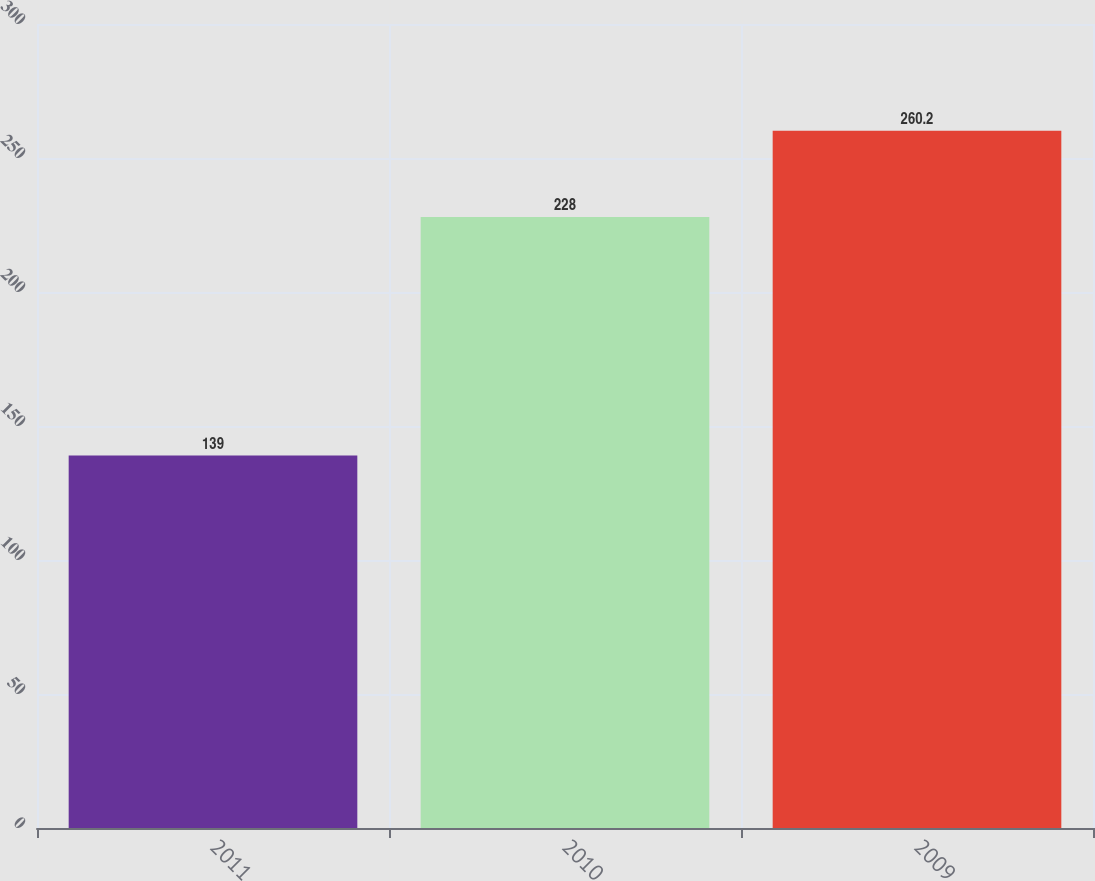Convert chart to OTSL. <chart><loc_0><loc_0><loc_500><loc_500><bar_chart><fcel>2011<fcel>2010<fcel>2009<nl><fcel>139<fcel>228<fcel>260.2<nl></chart> 